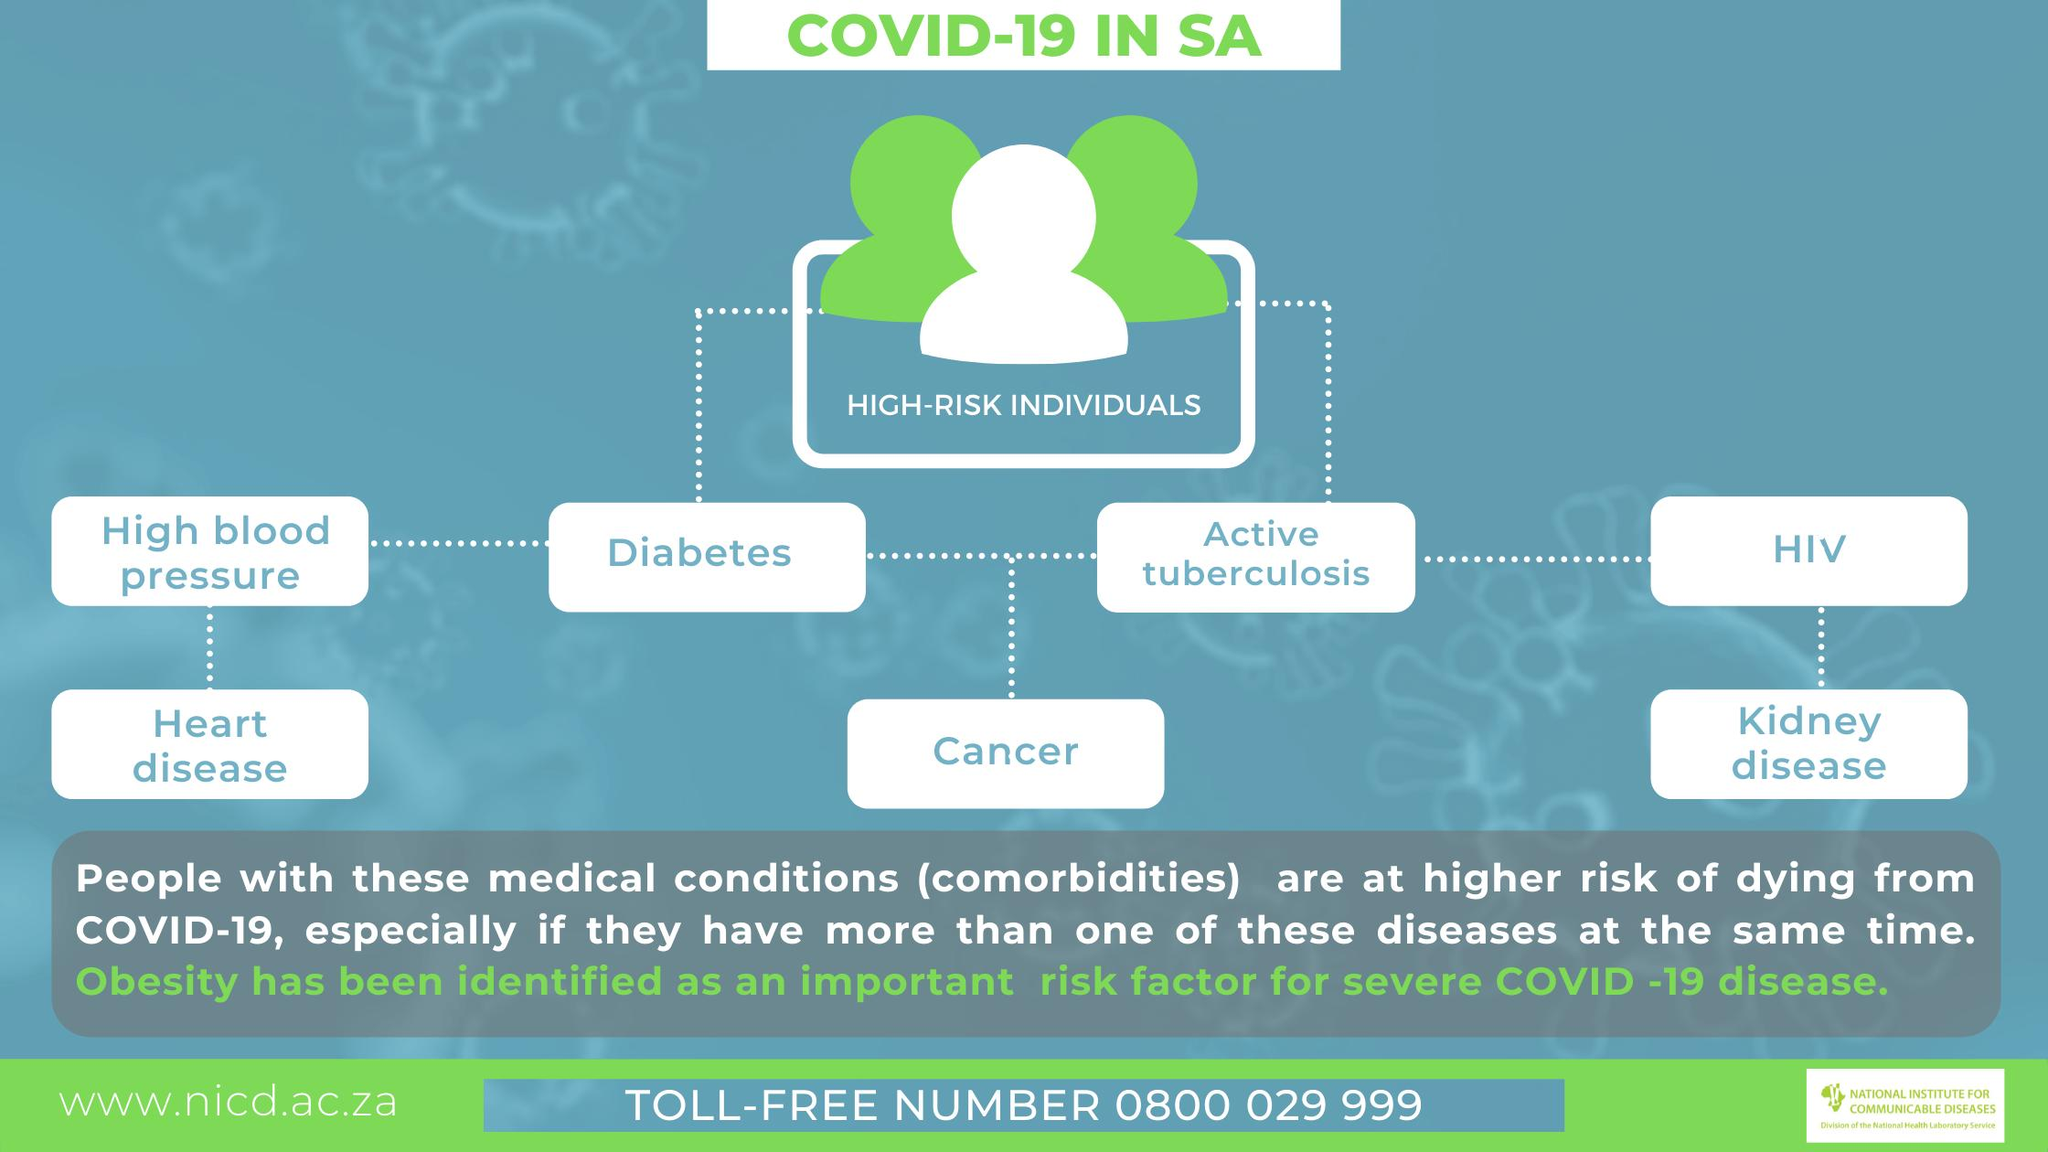Identify some key points in this picture. The second row of the chart lists three diseases. The chart lists 7 medical conditions. HIV is the most common sexually transmitted infection. However, active tuberculosis is the only disease that is more commonly left untreated among those infected with HIV. There are four diseases listed in the first row of the chart. High blood pressure is often associated with diabetes. 